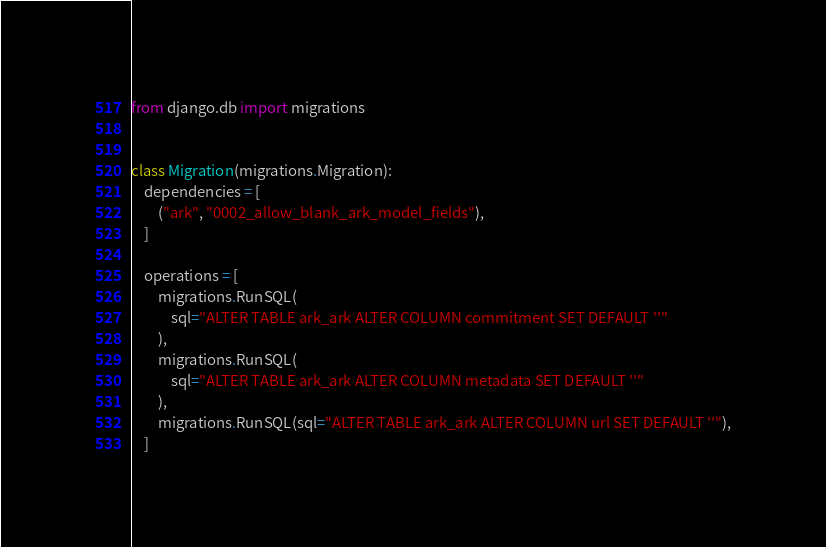Convert code to text. <code><loc_0><loc_0><loc_500><loc_500><_Python_>from django.db import migrations


class Migration(migrations.Migration):
    dependencies = [
        ("ark", "0002_allow_blank_ark_model_fields"),
    ]

    operations = [
        migrations.RunSQL(
            sql="ALTER TABLE ark_ark ALTER COLUMN commitment SET DEFAULT ''"
        ),
        migrations.RunSQL(
            sql="ALTER TABLE ark_ark ALTER COLUMN metadata SET DEFAULT ''"
        ),
        migrations.RunSQL(sql="ALTER TABLE ark_ark ALTER COLUMN url SET DEFAULT ''"),
    ]
</code> 